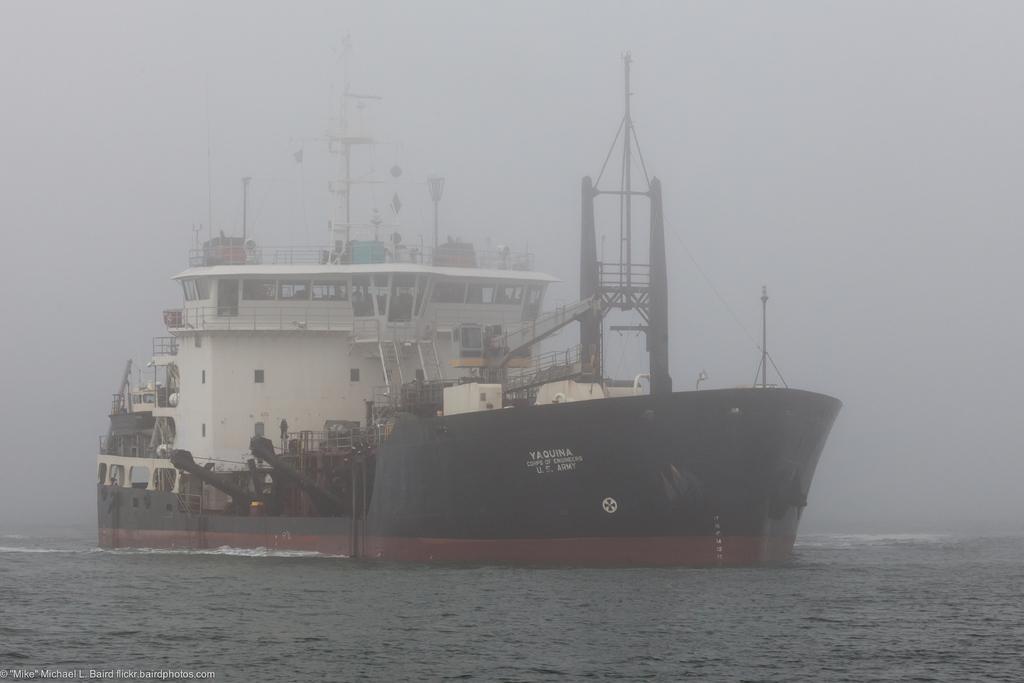Can you describe this image briefly? In the image there is a ship sailing on the sea, there are different equipment inside the ship and the climate is very cool with fog. 